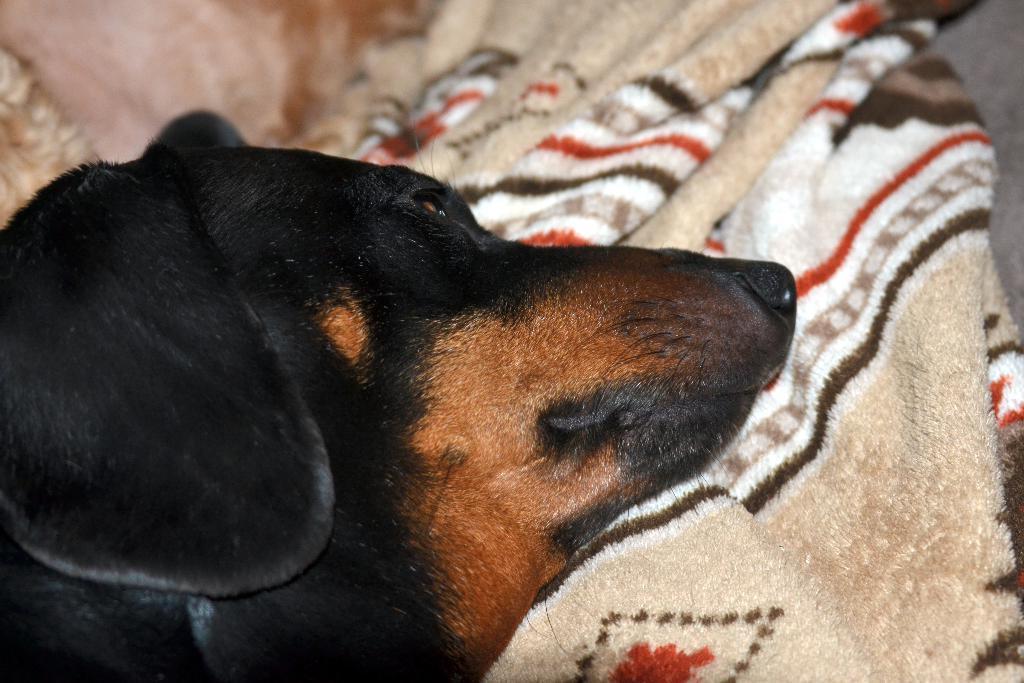Please provide a concise description of this image. In this image, we can see a black color dog and there is a blanket. 